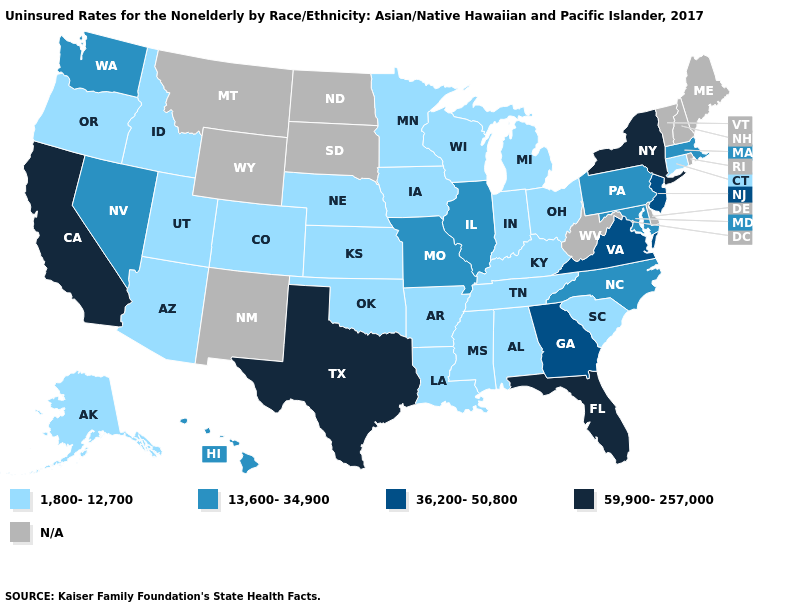Which states hav the highest value in the South?
Concise answer only. Florida, Texas. What is the value of Missouri?
Give a very brief answer. 13,600-34,900. What is the value of Florida?
Keep it brief. 59,900-257,000. What is the lowest value in the Northeast?
Answer briefly. 1,800-12,700. What is the lowest value in the South?
Short answer required. 1,800-12,700. Does the first symbol in the legend represent the smallest category?
Give a very brief answer. Yes. What is the highest value in the USA?
Keep it brief. 59,900-257,000. Does Connecticut have the lowest value in the Northeast?
Answer briefly. Yes. Name the states that have a value in the range 13,600-34,900?
Keep it brief. Hawaii, Illinois, Maryland, Massachusetts, Missouri, Nevada, North Carolina, Pennsylvania, Washington. What is the value of Michigan?
Be succinct. 1,800-12,700. Name the states that have a value in the range N/A?
Give a very brief answer. Delaware, Maine, Montana, New Hampshire, New Mexico, North Dakota, Rhode Island, South Dakota, Vermont, West Virginia, Wyoming. 